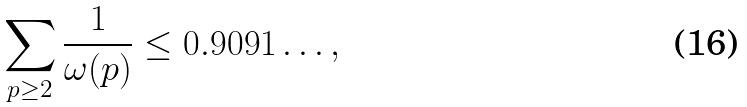<formula> <loc_0><loc_0><loc_500><loc_500>\sum _ { p \geq 2 } \frac { 1 } { \omega ( p ) } \leq 0 . 9 0 9 1 \dots ,</formula> 